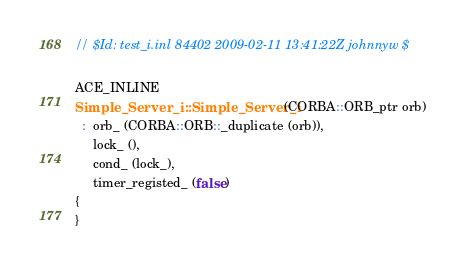Convert code to text. <code><loc_0><loc_0><loc_500><loc_500><_C++_>// $Id: test_i.inl 84402 2009-02-11 13:41:22Z johnnyw $

ACE_INLINE
Simple_Server_i::Simple_Server_i (CORBA::ORB_ptr orb)
  :  orb_ (CORBA::ORB::_duplicate (orb)),
     lock_ (),
     cond_ (lock_),
     timer_registed_ (false)
{
}
</code> 